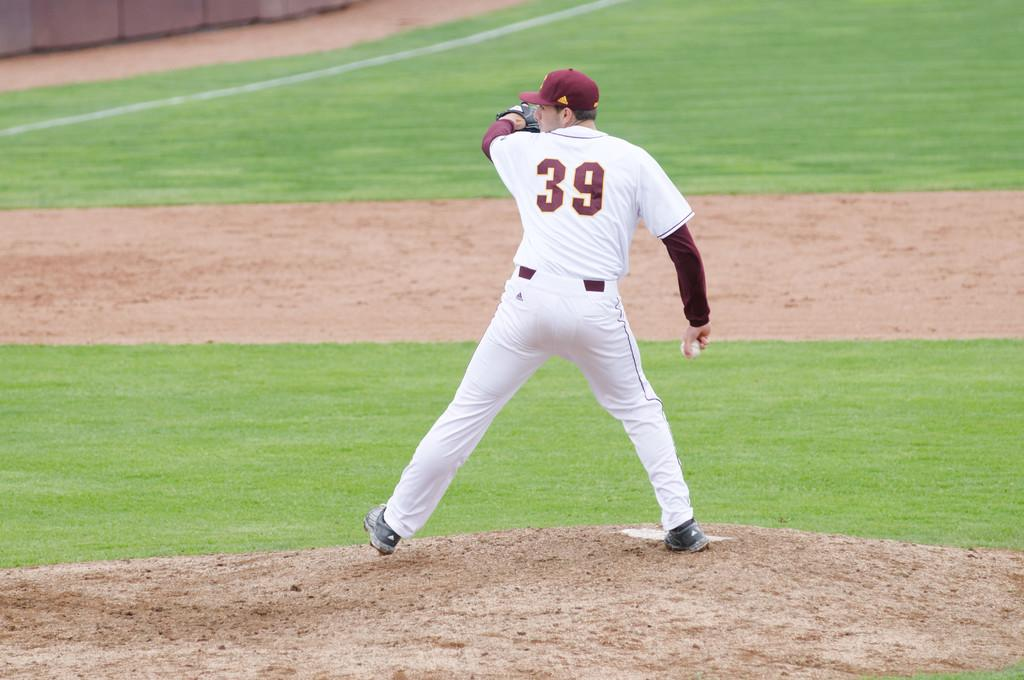<image>
Present a compact description of the photo's key features. A baseball pitcher with the number 39 on the back of his jersey. 